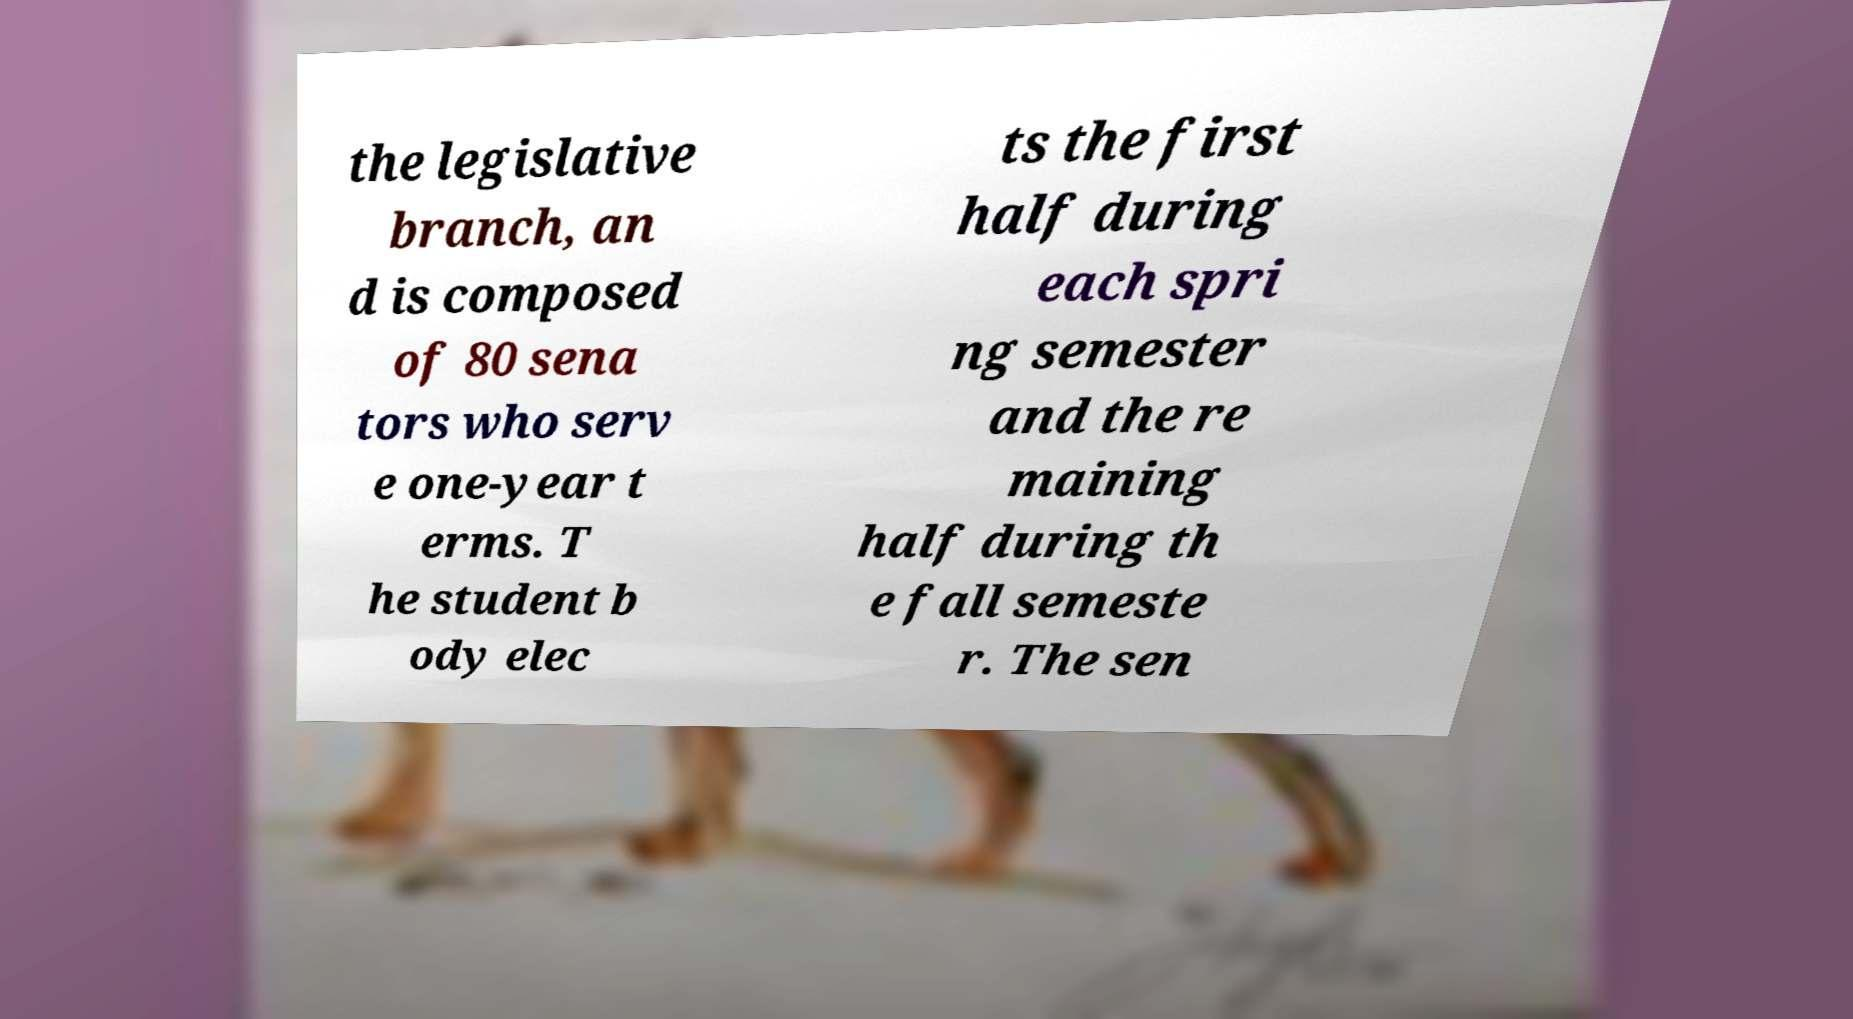What messages or text are displayed in this image? I need them in a readable, typed format. the legislative branch, an d is composed of 80 sena tors who serv e one-year t erms. T he student b ody elec ts the first half during each spri ng semester and the re maining half during th e fall semeste r. The sen 